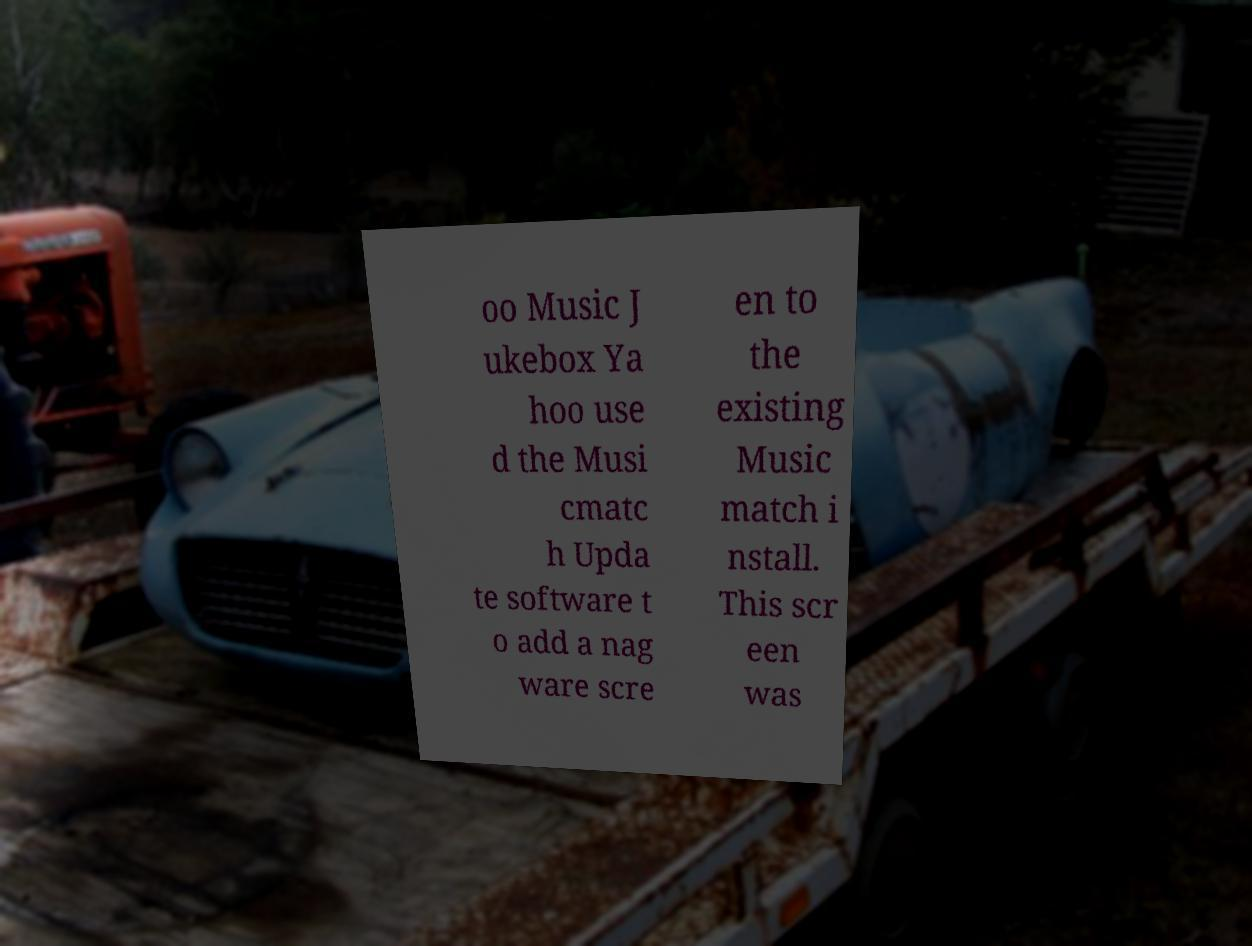I need the written content from this picture converted into text. Can you do that? oo Music J ukebox Ya hoo use d the Musi cmatc h Upda te software t o add a nag ware scre en to the existing Music match i nstall. This scr een was 